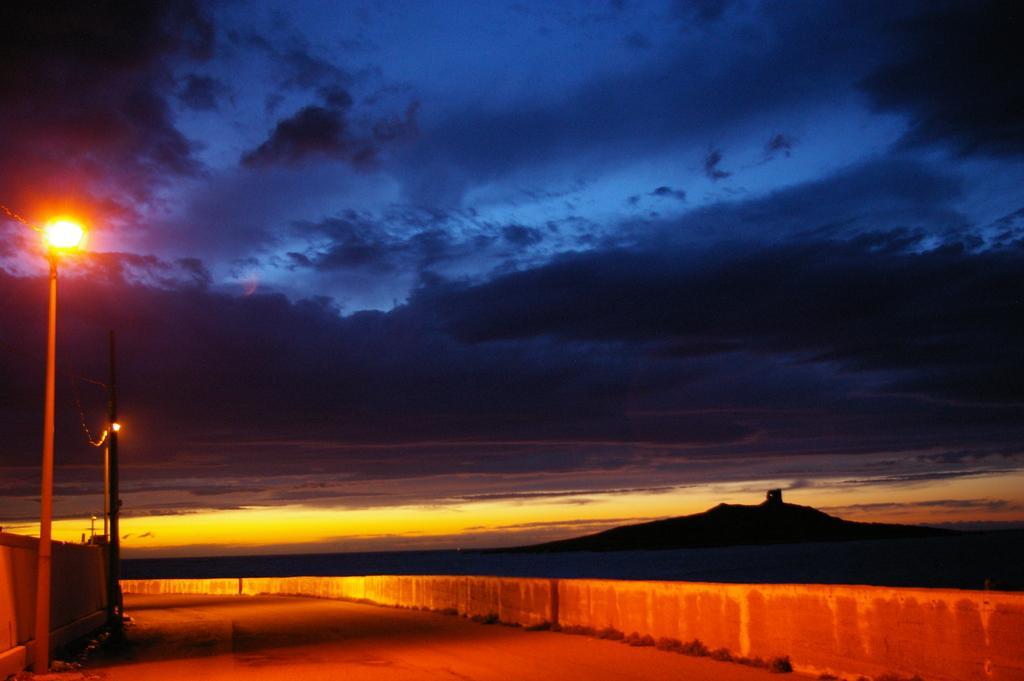Can you describe this image briefly? In this picture we can see the road, grass, walls, light poles, mountain and in the background we can see the sky with clouds. 